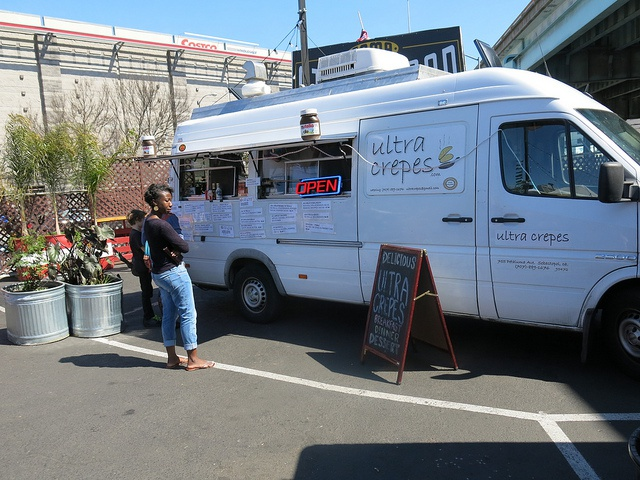Describe the objects in this image and their specific colors. I can see truck in lightblue, gray, black, and lightgray tones, potted plant in lightblue, gray, darkgray, lightgray, and black tones, potted plant in lightblue, darkgray, black, gray, and lightgray tones, people in lightblue, black, navy, and gray tones, and people in lightblue, black, gray, and maroon tones in this image. 